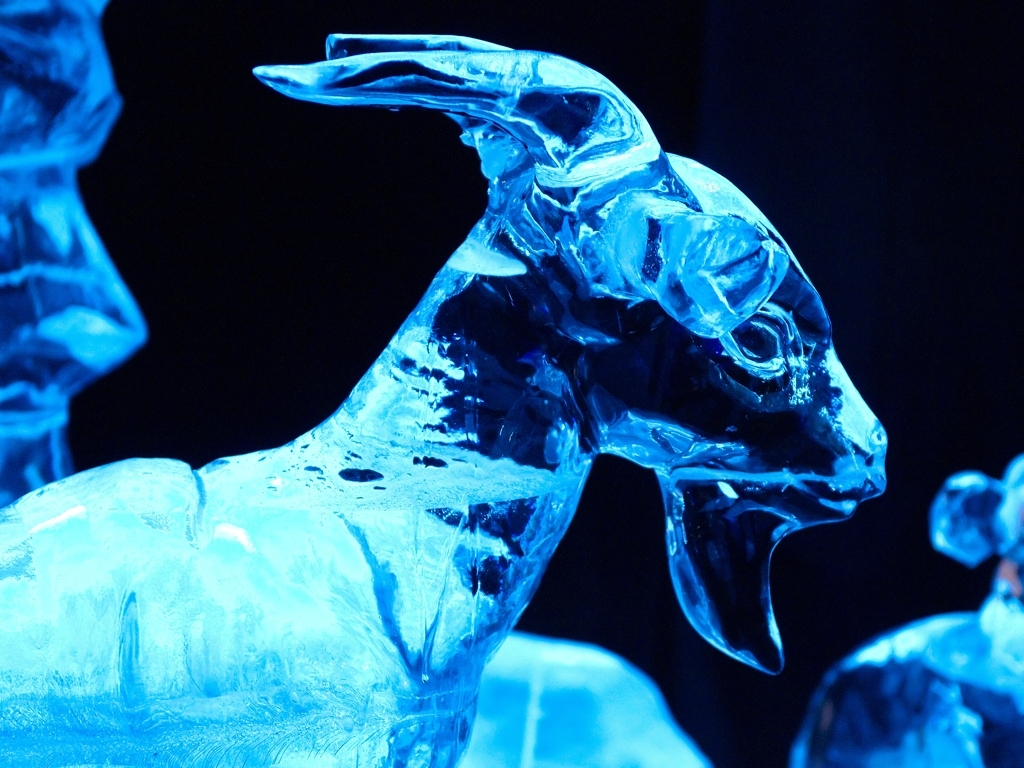Could you tell me about the techniques that might have been used to create this sculpture? Certainly, the creation of an ice sculpture like this one likely involved a combination of power tools for the rough shaping, such as chain saws and specialty ice drills, as well as hand tools like chisels, carving knives, and fine detail picks. Artisans must work quickly and precisely to achieve the nuanced textures and forms before the medium begins to melt. The finishing touches may include smoothing surfaces with heat guns or irons to achieve a translucent quality that catches light in a captivating way. 